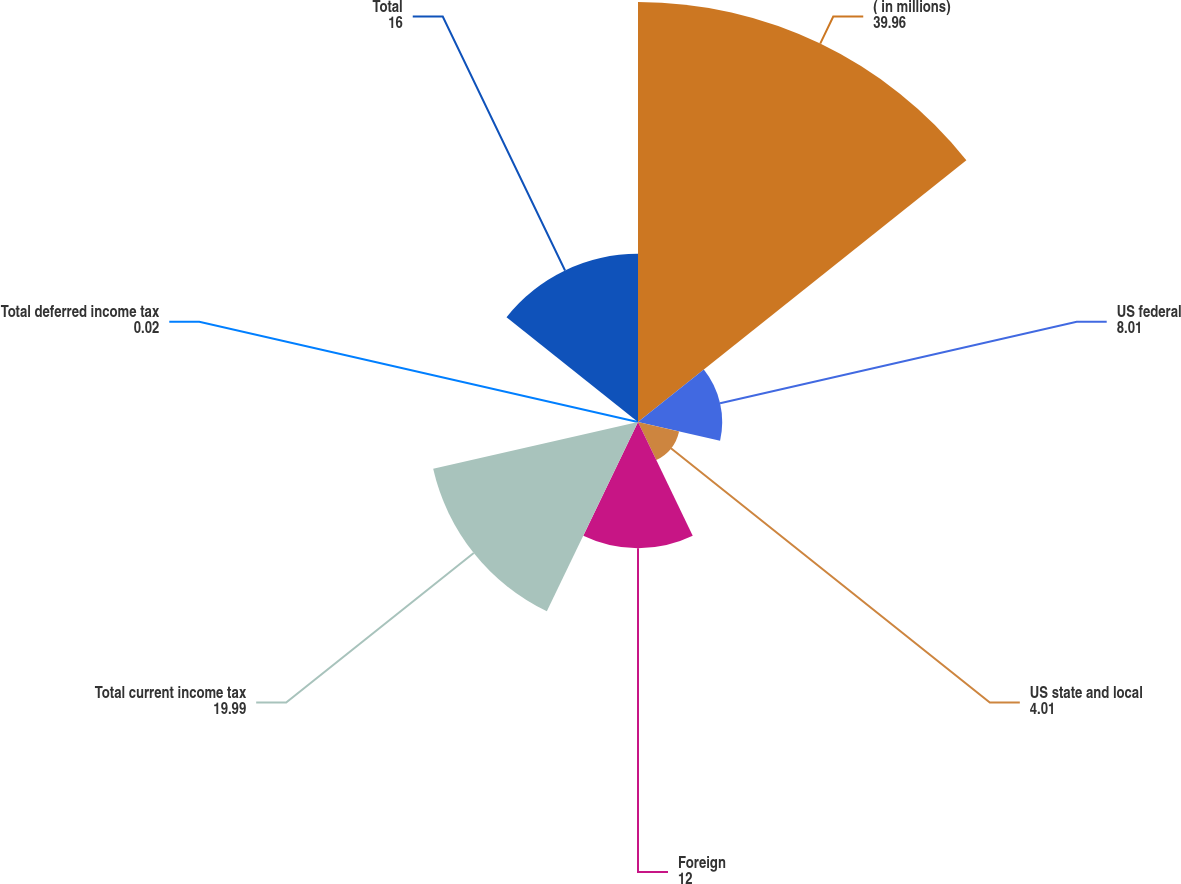Convert chart. <chart><loc_0><loc_0><loc_500><loc_500><pie_chart><fcel>( in millions)<fcel>US federal<fcel>US state and local<fcel>Foreign<fcel>Total current income tax<fcel>Total deferred income tax<fcel>Total<nl><fcel>39.96%<fcel>8.01%<fcel>4.01%<fcel>12.0%<fcel>19.99%<fcel>0.02%<fcel>16.0%<nl></chart> 